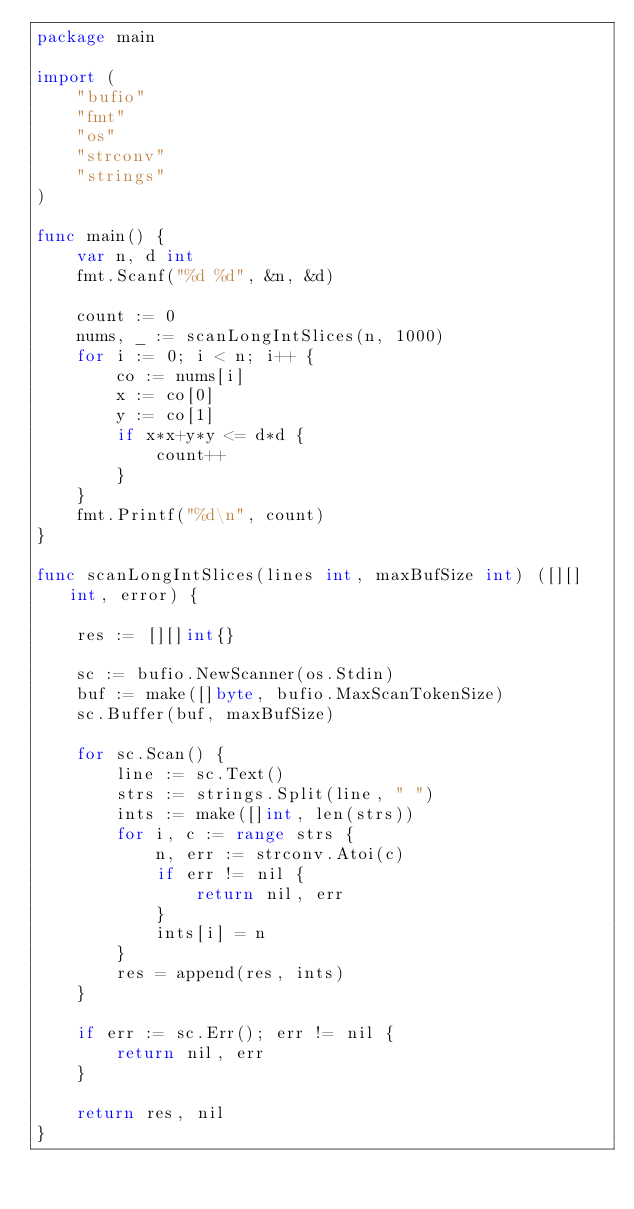<code> <loc_0><loc_0><loc_500><loc_500><_Go_>package main

import (
	"bufio"
	"fmt"
	"os"
	"strconv"
	"strings"
)

func main() {
	var n, d int
	fmt.Scanf("%d %d", &n, &d)

	count := 0
	nums, _ := scanLongIntSlices(n, 1000)
	for i := 0; i < n; i++ {
		co := nums[i]
		x := co[0]
		y := co[1]
		if x*x+y*y <= d*d {
			count++
		}
	}
	fmt.Printf("%d\n", count)
}

func scanLongIntSlices(lines int, maxBufSize int) ([][]int, error) {

	res := [][]int{}

	sc := bufio.NewScanner(os.Stdin)
	buf := make([]byte, bufio.MaxScanTokenSize)
	sc.Buffer(buf, maxBufSize)

	for sc.Scan() {
		line := sc.Text()
		strs := strings.Split(line, " ")
		ints := make([]int, len(strs))
		for i, c := range strs {
			n, err := strconv.Atoi(c)
			if err != nil {
				return nil, err
			}
			ints[i] = n
		}
		res = append(res, ints)
	}

	if err := sc.Err(); err != nil {
		return nil, err
	}

	return res, nil
}
</code> 